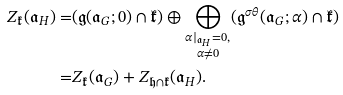<formula> <loc_0><loc_0><loc_500><loc_500>Z _ { \mathfrak { k } } ( { \mathfrak { a } } _ { H } ) = & ( { \mathfrak { g } } ( { \mathfrak { a } } _ { G } ; 0 ) \cap { \mathfrak { k } } ) \oplus \bigoplus _ { \substack { \alpha | _ { { \mathfrak { a } } _ { H } } = 0 , \\ \alpha \ne 0 } } ( { \mathfrak { g } } ^ { \sigma \theta } ( { \mathfrak { a } } _ { G } ; \alpha ) \cap { \mathfrak { k } } ) \\ = & Z _ { \mathfrak { k } } ( { \mathfrak { a } } _ { G } ) + Z _ { \mathfrak { h } \cap \mathfrak { k } } ( { \mathfrak { a } } _ { H } ) .</formula> 